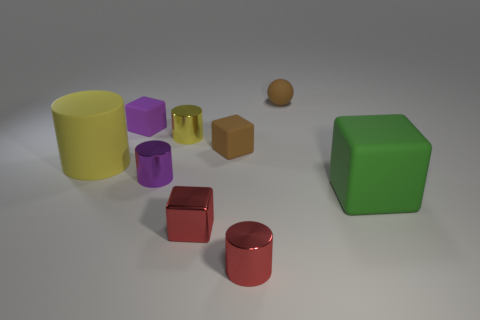Subtract all tiny purple cylinders. How many cylinders are left? 3 Subtract all cyan balls. How many yellow cylinders are left? 2 Subtract all cubes. How many objects are left? 5 Subtract all green blocks. How many blocks are left? 3 Subtract all small purple objects. Subtract all tiny rubber balls. How many objects are left? 6 Add 8 large cylinders. How many large cylinders are left? 9 Add 9 big blue balls. How many big blue balls exist? 9 Subtract 1 brown balls. How many objects are left? 8 Subtract all gray cylinders. Subtract all green blocks. How many cylinders are left? 4 